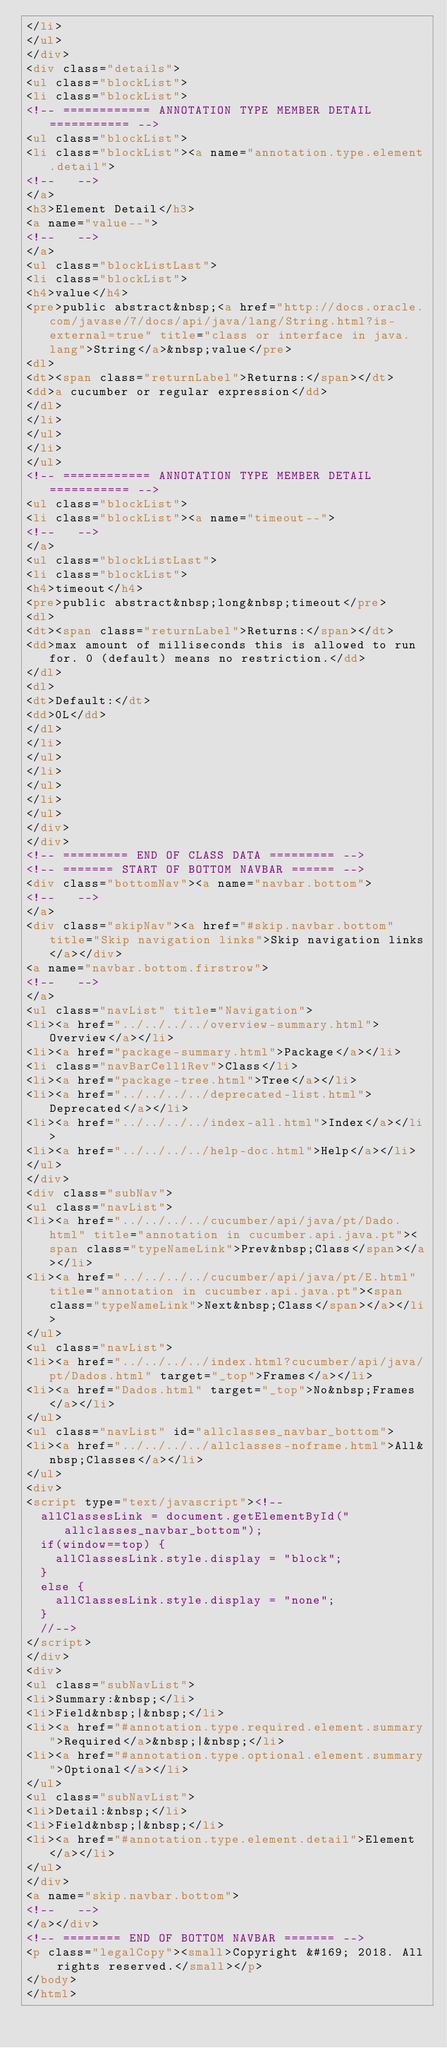Convert code to text. <code><loc_0><loc_0><loc_500><loc_500><_HTML_></li>
</ul>
</div>
<div class="details">
<ul class="blockList">
<li class="blockList">
<!-- ============ ANNOTATION TYPE MEMBER DETAIL =========== -->
<ul class="blockList">
<li class="blockList"><a name="annotation.type.element.detail">
<!--   -->
</a>
<h3>Element Detail</h3>
<a name="value--">
<!--   -->
</a>
<ul class="blockListLast">
<li class="blockList">
<h4>value</h4>
<pre>public abstract&nbsp;<a href="http://docs.oracle.com/javase/7/docs/api/java/lang/String.html?is-external=true" title="class or interface in java.lang">String</a>&nbsp;value</pre>
<dl>
<dt><span class="returnLabel">Returns:</span></dt>
<dd>a cucumber or regular expression</dd>
</dl>
</li>
</ul>
</li>
</ul>
<!-- ============ ANNOTATION TYPE MEMBER DETAIL =========== -->
<ul class="blockList">
<li class="blockList"><a name="timeout--">
<!--   -->
</a>
<ul class="blockListLast">
<li class="blockList">
<h4>timeout</h4>
<pre>public abstract&nbsp;long&nbsp;timeout</pre>
<dl>
<dt><span class="returnLabel">Returns:</span></dt>
<dd>max amount of milliseconds this is allowed to run for. 0 (default) means no restriction.</dd>
</dl>
<dl>
<dt>Default:</dt>
<dd>0L</dd>
</dl>
</li>
</ul>
</li>
</ul>
</li>
</ul>
</div>
</div>
<!-- ========= END OF CLASS DATA ========= -->
<!-- ======= START OF BOTTOM NAVBAR ====== -->
<div class="bottomNav"><a name="navbar.bottom">
<!--   -->
</a>
<div class="skipNav"><a href="#skip.navbar.bottom" title="Skip navigation links">Skip navigation links</a></div>
<a name="navbar.bottom.firstrow">
<!--   -->
</a>
<ul class="navList" title="Navigation">
<li><a href="../../../../overview-summary.html">Overview</a></li>
<li><a href="package-summary.html">Package</a></li>
<li class="navBarCell1Rev">Class</li>
<li><a href="package-tree.html">Tree</a></li>
<li><a href="../../../../deprecated-list.html">Deprecated</a></li>
<li><a href="../../../../index-all.html">Index</a></li>
<li><a href="../../../../help-doc.html">Help</a></li>
</ul>
</div>
<div class="subNav">
<ul class="navList">
<li><a href="../../../../cucumber/api/java/pt/Dado.html" title="annotation in cucumber.api.java.pt"><span class="typeNameLink">Prev&nbsp;Class</span></a></li>
<li><a href="../../../../cucumber/api/java/pt/E.html" title="annotation in cucumber.api.java.pt"><span class="typeNameLink">Next&nbsp;Class</span></a></li>
</ul>
<ul class="navList">
<li><a href="../../../../index.html?cucumber/api/java/pt/Dados.html" target="_top">Frames</a></li>
<li><a href="Dados.html" target="_top">No&nbsp;Frames</a></li>
</ul>
<ul class="navList" id="allclasses_navbar_bottom">
<li><a href="../../../../allclasses-noframe.html">All&nbsp;Classes</a></li>
</ul>
<div>
<script type="text/javascript"><!--
  allClassesLink = document.getElementById("allclasses_navbar_bottom");
  if(window==top) {
    allClassesLink.style.display = "block";
  }
  else {
    allClassesLink.style.display = "none";
  }
  //-->
</script>
</div>
<div>
<ul class="subNavList">
<li>Summary:&nbsp;</li>
<li>Field&nbsp;|&nbsp;</li>
<li><a href="#annotation.type.required.element.summary">Required</a>&nbsp;|&nbsp;</li>
<li><a href="#annotation.type.optional.element.summary">Optional</a></li>
</ul>
<ul class="subNavList">
<li>Detail:&nbsp;</li>
<li>Field&nbsp;|&nbsp;</li>
<li><a href="#annotation.type.element.detail">Element</a></li>
</ul>
</div>
<a name="skip.navbar.bottom">
<!--   -->
</a></div>
<!-- ======== END OF BOTTOM NAVBAR ======= -->
<p class="legalCopy"><small>Copyright &#169; 2018. All rights reserved.</small></p>
</body>
</html>
</code> 